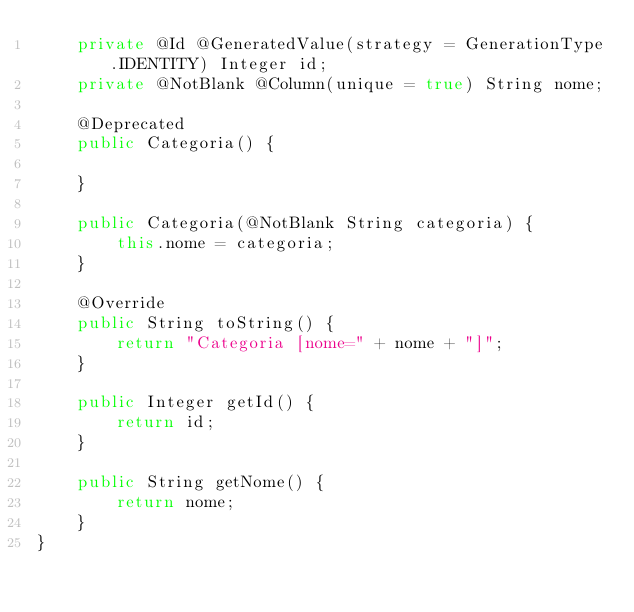Convert code to text. <code><loc_0><loc_0><loc_500><loc_500><_Java_>	private @Id @GeneratedValue(strategy = GenerationType.IDENTITY) Integer id;
	private @NotBlank @Column(unique = true) String nome;
	
	@Deprecated
	public Categoria() {
		
	}
	
	public Categoria(@NotBlank String categoria) {
		this.nome = categoria;
	}

	@Override
	public String toString() {
		return "Categoria [nome=" + nome + "]";
	}

	public Integer getId() {
		return id;
	}

	public String getNome() {
		return nome;
	}
}
</code> 